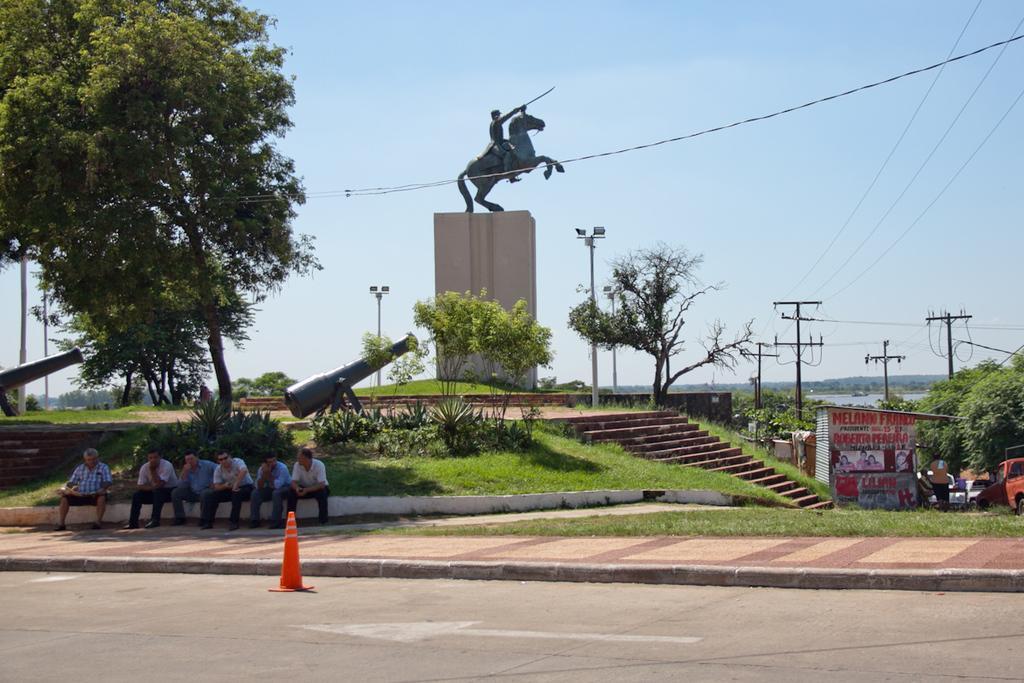Can you describe this image briefly? In this image I see the road, footpath and I see 6 men who are sitting and I see the green grass, plants, 2 cannons and the steps over here. In the background I see the statue of a horse and a man sitting on it and I see the poles, wires, trees, few cars over here and I see pictures of persons and something is written over here and I see the sky. 